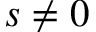<formula> <loc_0><loc_0><loc_500><loc_500>s \neq 0</formula> 